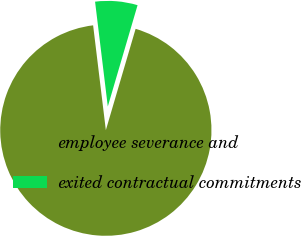<chart> <loc_0><loc_0><loc_500><loc_500><pie_chart><fcel>employee severance and<fcel>exited contractual commitments<nl><fcel>93.53%<fcel>6.47%<nl></chart> 